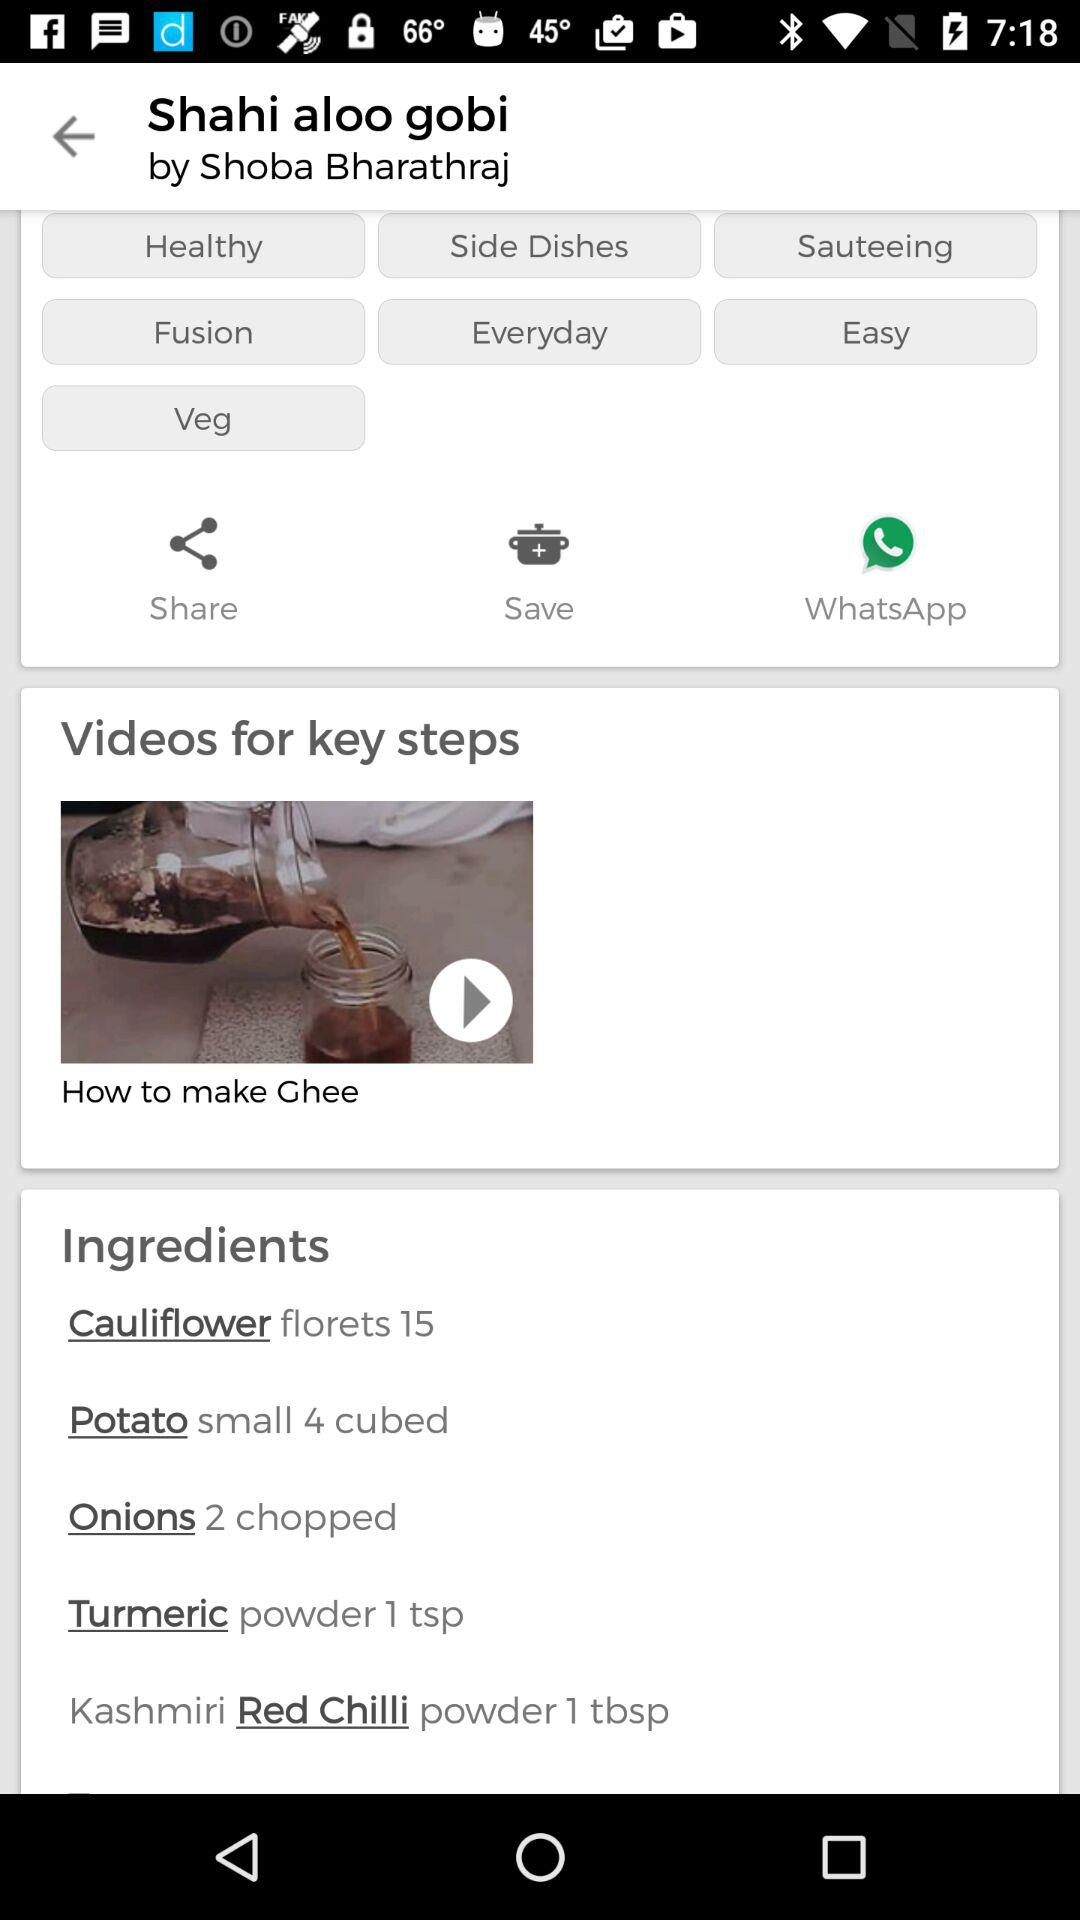What are the ingredients required for "Shahi Aloo Gobi"? The ingredients are "Cauliflower florets 15", "Potato small 4 cubed", "Onions 2 chopped", "Turmeric powder 1 tsp", and "Kashmiri Red Chilli powder 1 tbsp". 